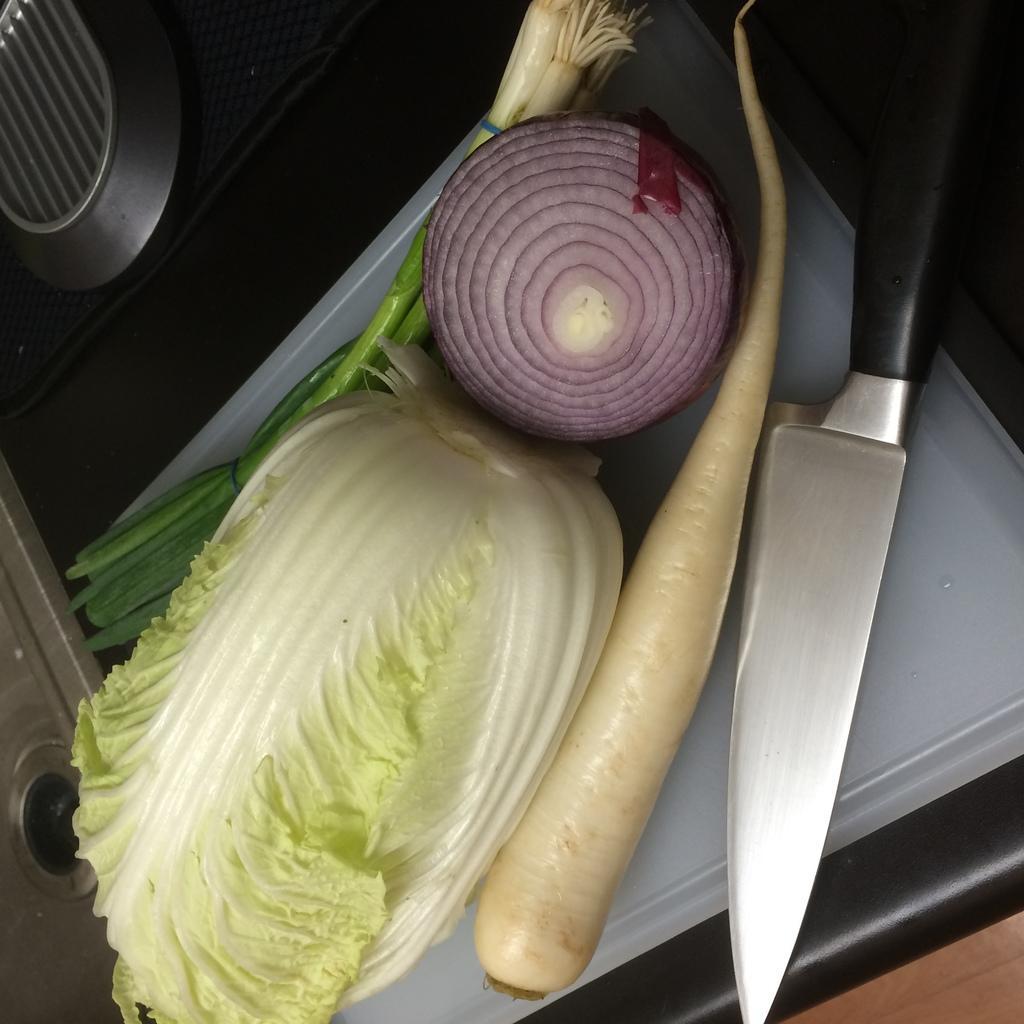Please provide a concise description of this image. In this image I can see a white colour thing and on it I can see a knife, a radish, an onion, a cabbage and few spring onions. On the top left corner of this image I can see a silver colour thing. 